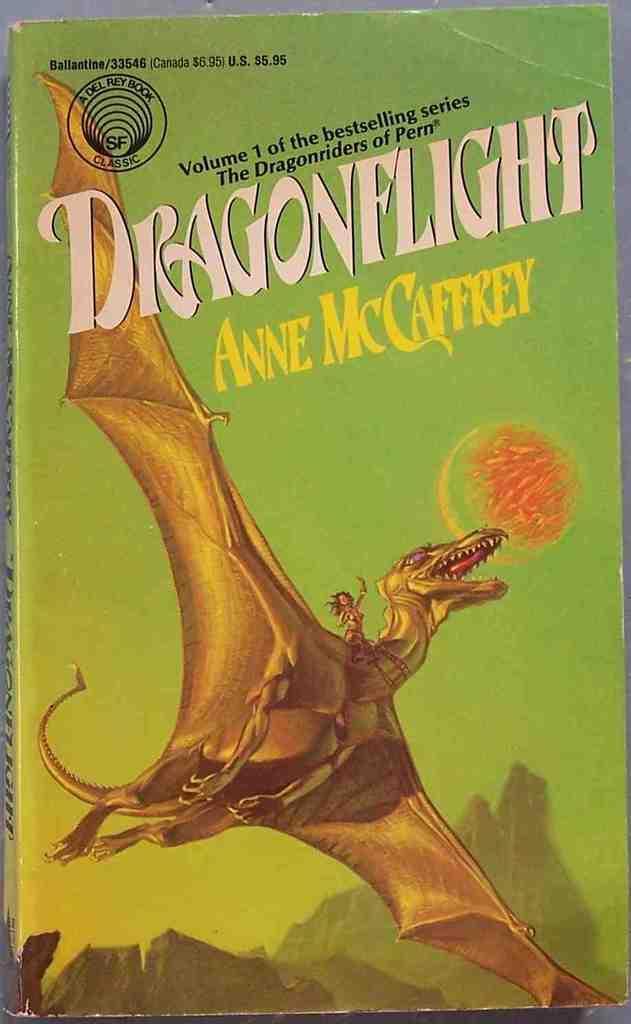How would you summarize this image in a sentence or two? In this image we can see a book. On the book we can see a painting of a dragon. Also something is written on the book. 